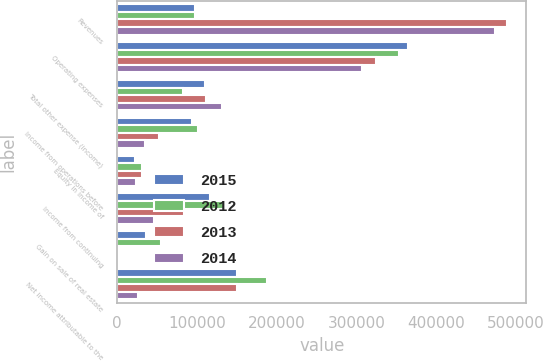<chart> <loc_0><loc_0><loc_500><loc_500><stacked_bar_chart><ecel><fcel>Revenues<fcel>Operating expenses<fcel>Total other expense (income)<fcel>Income from operations before<fcel>Equity in income of<fcel>Income from continuing<fcel>Gain on sale of real estate<fcel>Net income attributable to the<nl><fcel>2015<fcel>97966.5<fcel>365098<fcel>110236<fcel>94429<fcel>22508<fcel>116937<fcel>35606<fcel>150056<nl><fcel>2012<fcel>97966.5<fcel>353348<fcel>83046<fcel>101504<fcel>31270<fcel>133770<fcel>55077<fcel>187390<nl><fcel>2013<fcel>489007<fcel>324687<fcel>111741<fcel>52579<fcel>31718<fcel>84297<fcel>1703<fcel>149804<nl><fcel>2014<fcel>473929<fcel>307493<fcel>131240<fcel>35196<fcel>23807<fcel>45779<fcel>2158<fcel>25867<nl></chart> 